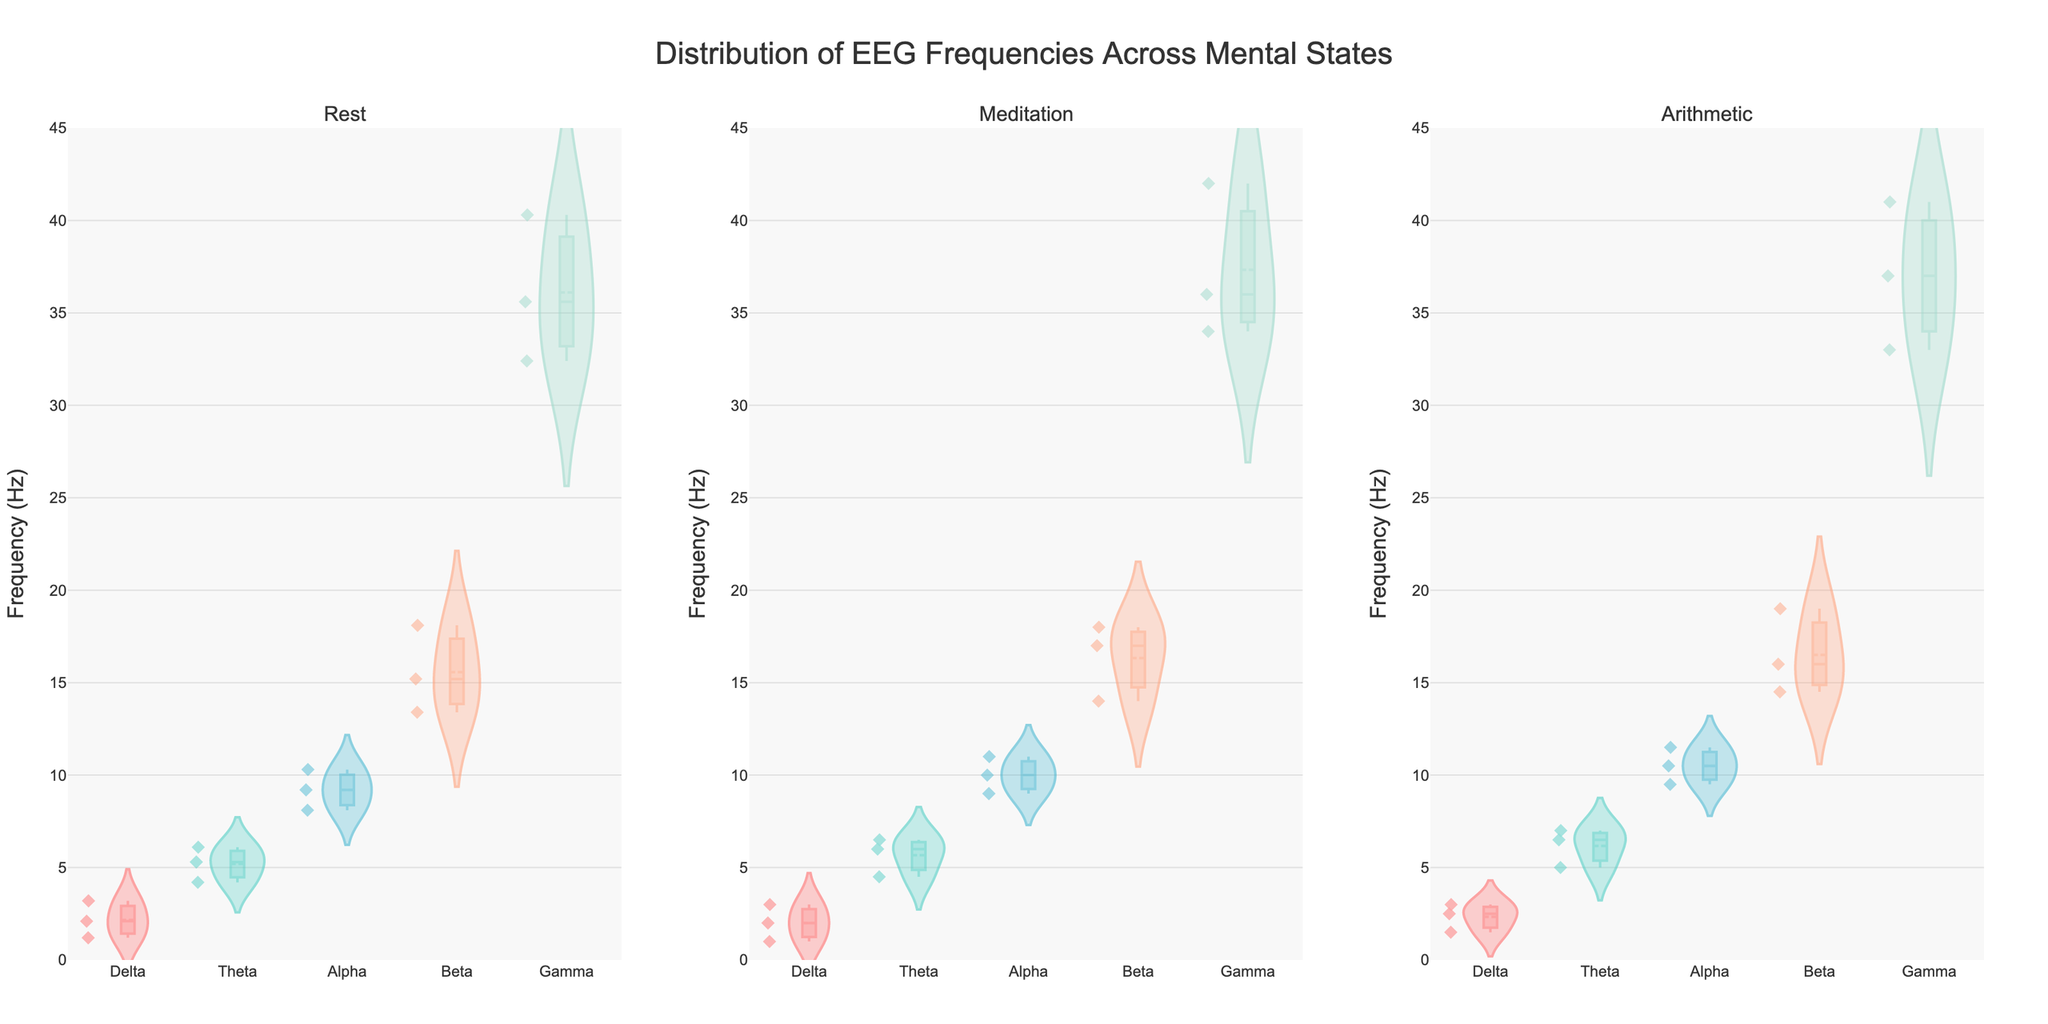What's the title of the plot? The title of the plot is displayed at the top center of the figure.
Answer: Distribution of EEG Frequencies Across Mental States What is the range of frequencies being plotted on the y-axis? Look at the y-axis range to determine the lowest and highest values.
Answer: 0 to 45 Hz Which mental state has the most widespread distribution in the Gamma frequency range? Compare the widths of the violin plots for the Gamma frequency range across all mental states.
Answer: Meditation Which mental state has the highest median value in the Beta frequency range? Look at the horizontal line within the Beta violin plot for each mental state to find the highest median.
Answer: Rest In which frequency range does the Meditation mental state have the highest distribution peak? Observe the violin plot for Meditation and identify the tallest and widest section within one frequency range.
Answer: Gamma What is the mean frequency value for the Alpha range during Rest? Look for the mean line within the Alpha violin plot under Rest.
Answer: Approximately 9.2 Hz Which mental state has the lowest median value in the Delta frequency range? Compare the horizontal lines within the Delta violin plots across all mental states to find the lowest median.
Answer: Meditation Comparing Theta frequency ranges, which mental state shows a higher upper whisker? Analyze the upper whiskers (the top part of the violin plots) for the Theta range across mental states.
Answer: Meditation Which frequency range shows the least variability across all mental states? Determine the width and spread of the violin plots for each frequency range; the least variability corresponds to the narrowest plot.
Answer: Delta 